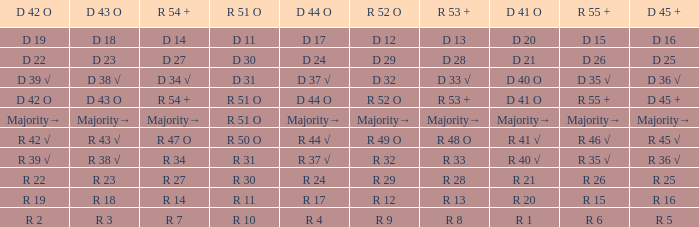Which R 51 O value corresponds to a D 42 O value of r 19? R 11. 